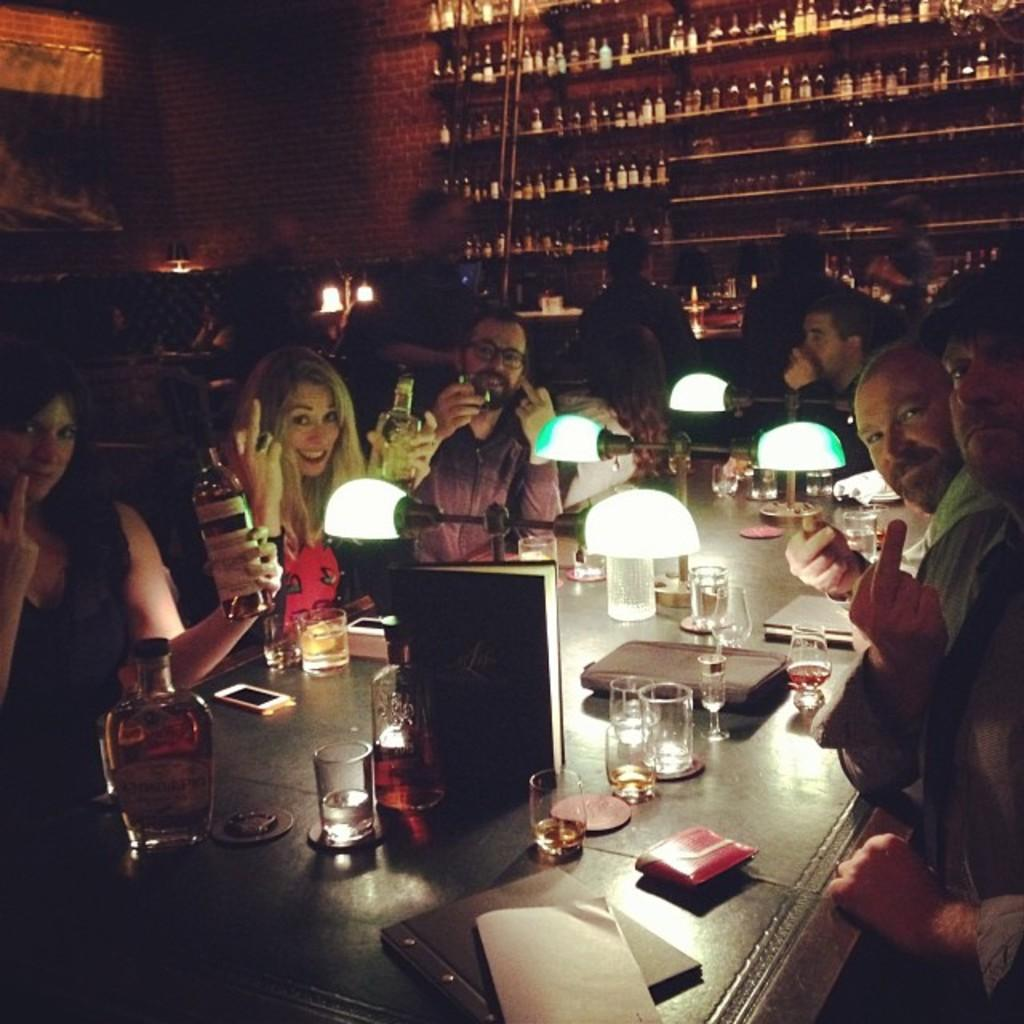How many people are in the image? There is a group of people in the image. What are the people doing in the image? The people are sitting on chairs. Where are the chairs located in relation to the table? The chairs are in front of a table. What can be seen on the table besides the chairs? There are glasses, books, and other objects on the table. What type of oil is being used to cook the eggs in the image? There are no eggs or oil present in the image. How many people are part of the crowd in the image? There is no crowd present in the image; it features a group of people sitting on chairs. 